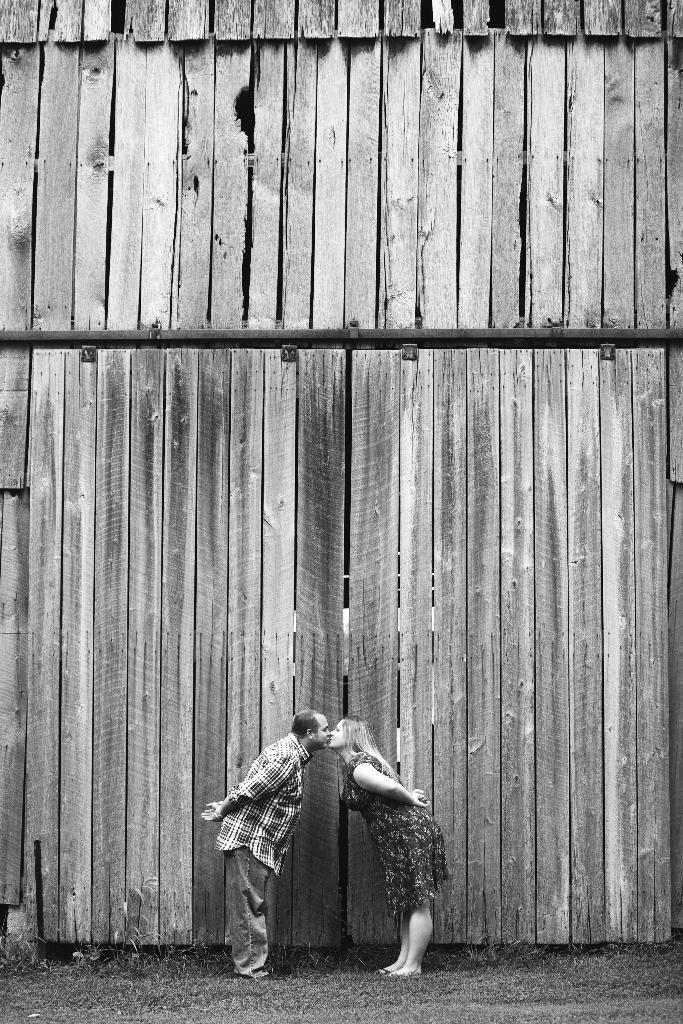Can you describe this image briefly? There is a man and a woman slightly bending and lift kissing with each other, on the grass on the ground, near a wooden wall. 